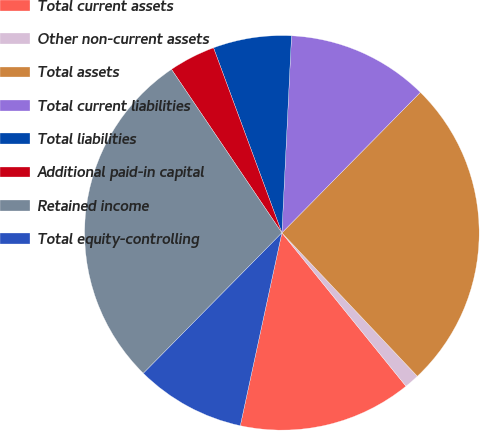Convert chart. <chart><loc_0><loc_0><loc_500><loc_500><pie_chart><fcel>Total current assets<fcel>Other non-current assets<fcel>Total assets<fcel>Total current liabilities<fcel>Total liabilities<fcel>Additional paid-in capital<fcel>Retained income<fcel>Total equity-controlling<nl><fcel>14.21%<fcel>1.22%<fcel>25.57%<fcel>11.61%<fcel>6.41%<fcel>3.82%<fcel>28.16%<fcel>9.01%<nl></chart> 